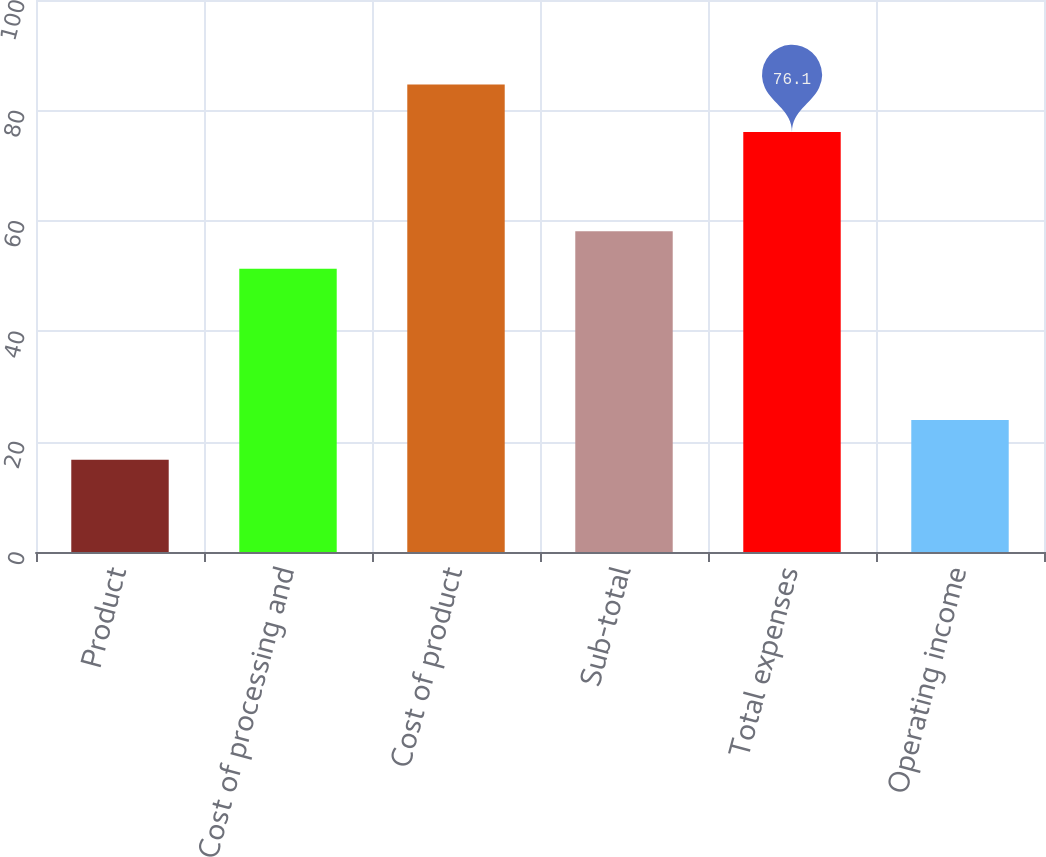<chart> <loc_0><loc_0><loc_500><loc_500><bar_chart><fcel>Product<fcel>Cost of processing and<fcel>Cost of product<fcel>Sub-total<fcel>Total expenses<fcel>Operating income<nl><fcel>16.7<fcel>51.3<fcel>84.7<fcel>58.1<fcel>76.1<fcel>23.9<nl></chart> 